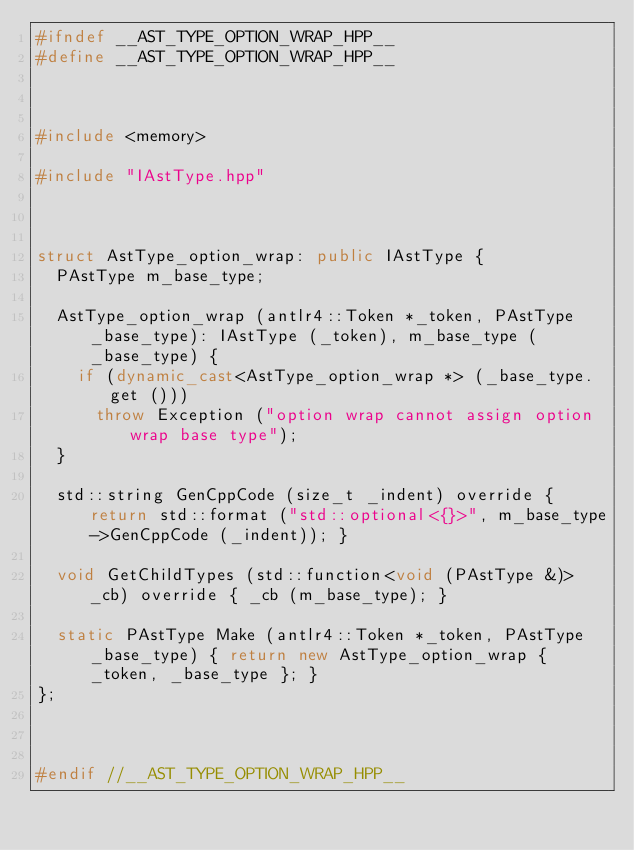Convert code to text. <code><loc_0><loc_0><loc_500><loc_500><_C++_>#ifndef __AST_TYPE_OPTION_WRAP_HPP__
#define __AST_TYPE_OPTION_WRAP_HPP__



#include <memory>

#include "IAstType.hpp"



struct AstType_option_wrap: public IAstType {
	PAstType m_base_type;

	AstType_option_wrap (antlr4::Token *_token, PAstType _base_type): IAstType (_token), m_base_type (_base_type) {
		if (dynamic_cast<AstType_option_wrap *> (_base_type.get ()))
			throw Exception ("option wrap cannot assign option wrap base type");
	}

	std::string GenCppCode (size_t _indent) override { return std::format ("std::optional<{}>", m_base_type->GenCppCode (_indent)); }

	void GetChildTypes (std::function<void (PAstType &)> _cb) override { _cb (m_base_type); }

	static PAstType Make (antlr4::Token *_token, PAstType _base_type) { return new AstType_option_wrap { _token, _base_type }; }
};



#endif //__AST_TYPE_OPTION_WRAP_HPP__
</code> 